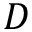<formula> <loc_0><loc_0><loc_500><loc_500>D</formula> 